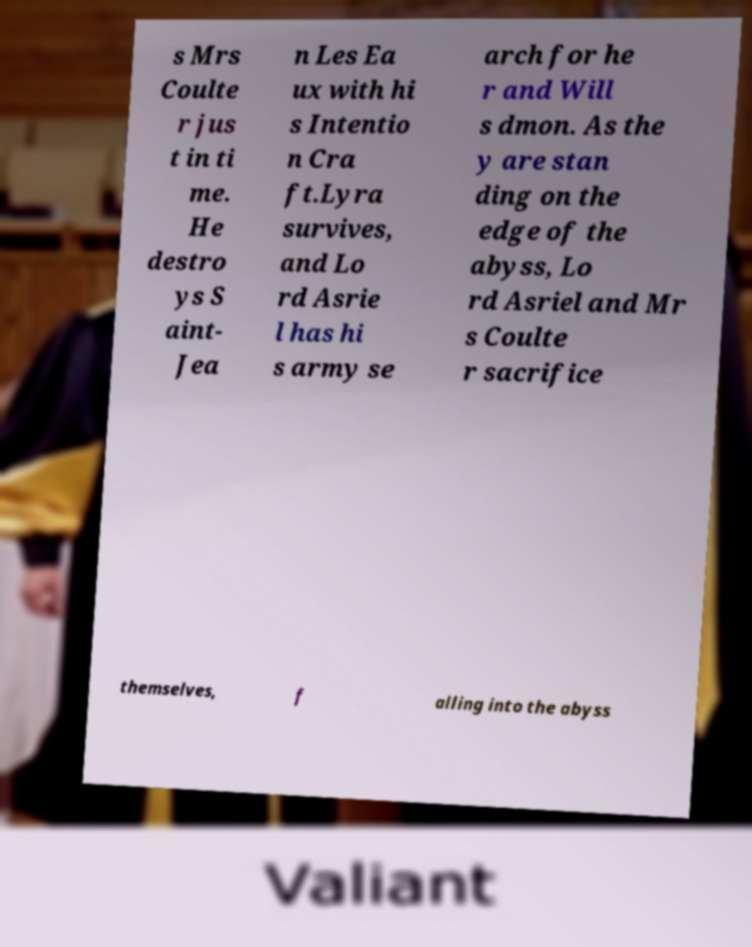There's text embedded in this image that I need extracted. Can you transcribe it verbatim? s Mrs Coulte r jus t in ti me. He destro ys S aint- Jea n Les Ea ux with hi s Intentio n Cra ft.Lyra survives, and Lo rd Asrie l has hi s army se arch for he r and Will s dmon. As the y are stan ding on the edge of the abyss, Lo rd Asriel and Mr s Coulte r sacrifice themselves, f alling into the abyss 